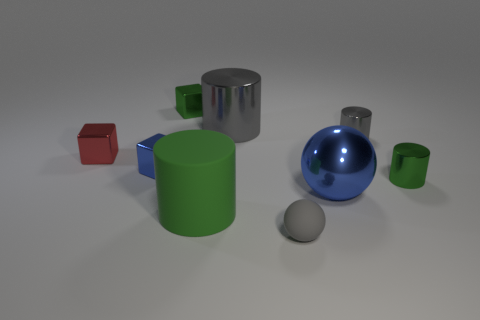There is a gray metal thing that is on the left side of the gray rubber object; is its size the same as the green metal thing that is right of the green matte object?
Provide a succinct answer. No. The green thing that is both left of the tiny sphere and behind the matte cylinder has what shape?
Keep it short and to the point. Cube. What is the color of the big thing to the right of the small object in front of the blue metallic ball?
Provide a short and direct response. Blue. Does the rubber sphere have the same color as the big thing that is right of the tiny rubber ball?
Keep it short and to the point. No. What is the gray thing that is to the left of the big blue thing and behind the big blue ball made of?
Provide a succinct answer. Metal. There is a green cylinder that is the same size as the metal ball; what is it made of?
Give a very brief answer. Rubber. There is a small cube that is the same color as the big sphere; what material is it?
Keep it short and to the point. Metal. What is the shape of the small gray object in front of the small cylinder that is in front of the red shiny thing?
Your answer should be very brief. Sphere. What number of tiny blue blocks are the same material as the large gray thing?
Provide a short and direct response. 1. The other thing that is the same material as the big green thing is what color?
Ensure brevity in your answer.  Gray. 